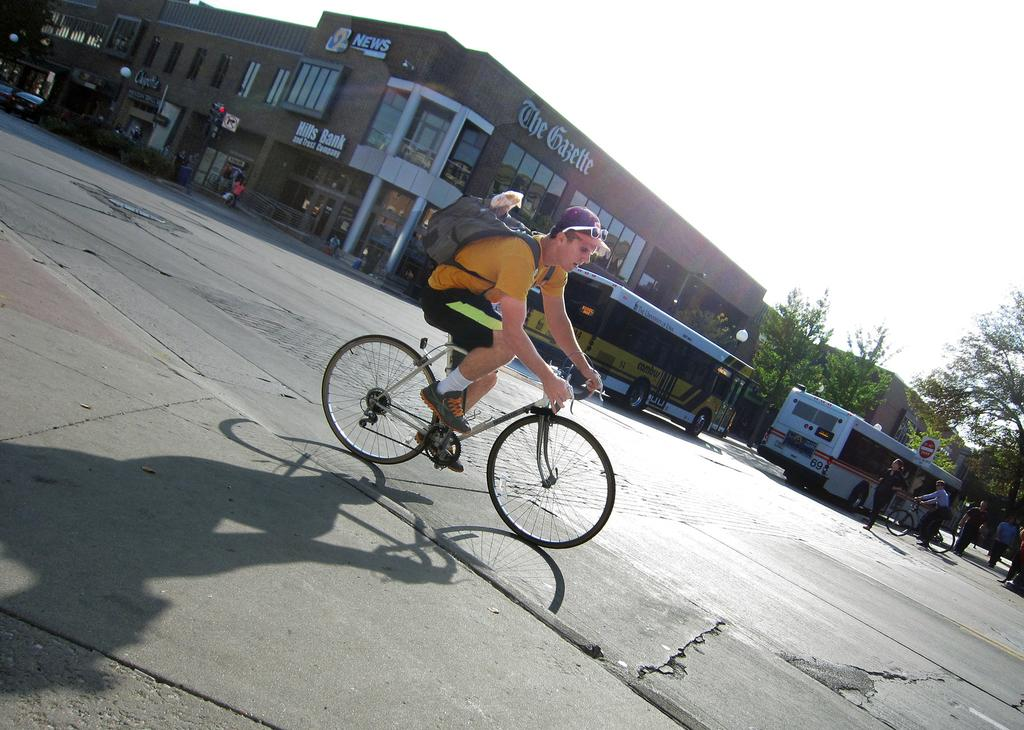What is the main subject in the foreground of the image? There is a man riding a bicycle in the foreground of the image. Where is the man riding the bicycle? The man is on the road. What can be seen in the background of the image? There are buses, persons walking, at least one person on a bicycle, a building, the sky, and trees in the background of the image. How long does it take for the tent to pass by in the image? There is no tent present in the image, so it cannot be determined how long it would take for it to pass by. 